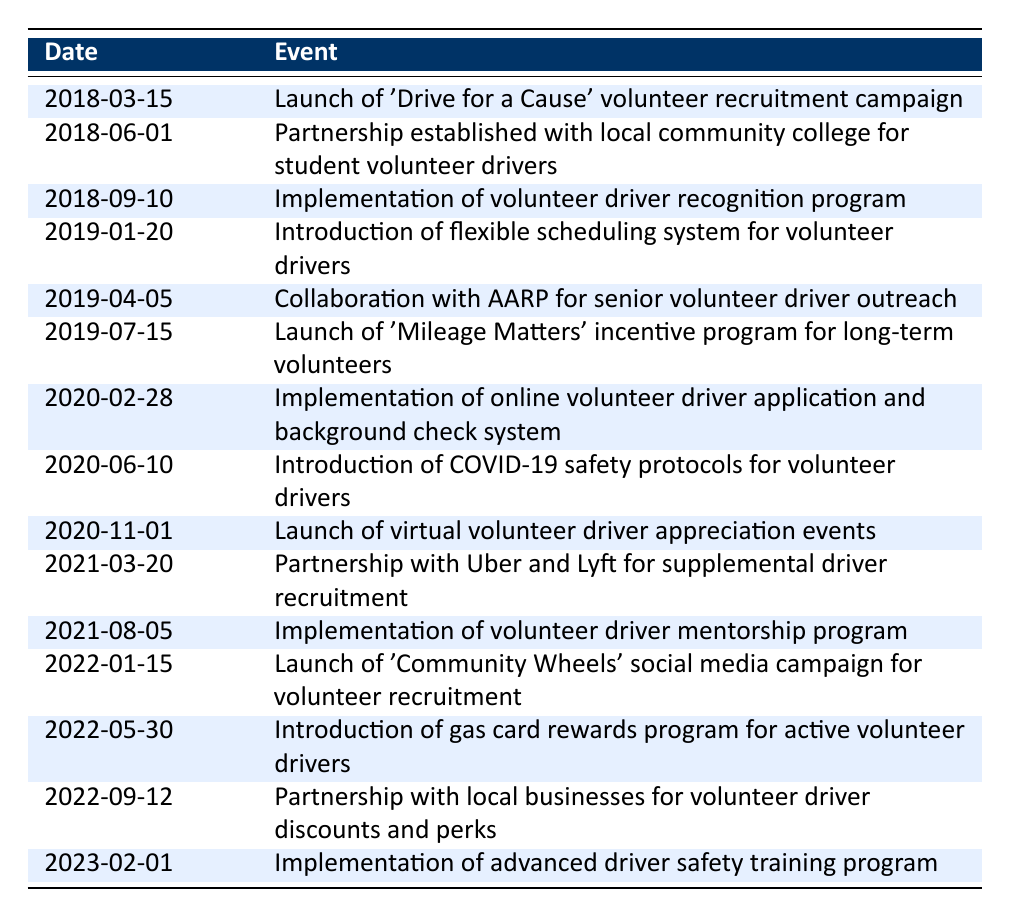What event marked the launch of the volunteer recruitment campaign? The event that marked the launch of the volunteer recruitment campaign is described in the table under the date 2018-03-15, which states "Launch of 'Drive for a Cause' volunteer recruitment campaign."
Answer: Launch of 'Drive for a Cause' volunteer recruitment campaign When did the introduction of the flexible scheduling system occur? Referring to the table, the introduction of the flexible scheduling system occurred on 2019-01-20. This date can be found directly in the date column associated with the relevant event.
Answer: 2019-01-20 How many initiatives were launched to recognize or appreciate volunteer drivers according to the timeline? There are two initiatives related to recognition or appreciation of volunteer drivers mentioned in the table: one on 2018-09-10 for the recognition program and another on 2020-11-01 for virtual appreciation events. Thus, the total is 2.
Answer: 2 Which partnership was established in 2021 to help with driver recruitment? The table indicates that a partnership with Uber and Lyft for supplemental driver recruitment was established on 2021-03-20. This information is directly retrievable from the relevant row.
Answer: Partnership with Uber and Lyft for supplemental driver recruitment Was there any initiative focused on senior volunteer drivers? Yes, according to the table, a collaboration with AARP for senior volunteer driver outreach was established on 2019-04-05, which confirms the initiative's focus on that demographic.
Answer: Yes What was the purpose of the 'Mileage Matters' incentive program that launched in July 2019? The 'Mileage Matters' incentive program launched on 2019-07-15 is explicitly stated in the table as aimed at recognizing long-term volunteers, suggesting its purpose was to incentivize continued involvement.
Answer: To incentivize long-term volunteers List the events that took place in 2020. Reviewing the timeline, three events took place in 2020: the implementation of an online volunteer driver application system on 2020-02-28, the introduction of COVID-19 safety protocols on 2020-06-10, and the launch of virtual appreciation events on 2020-11-01. Therefore, there are three events in total.
Answer: Three events What was the first event related to volunteer driver support in 2022? The first event related to volunteer driver support in 2022, according to the timeline, was the launch of 'Community Wheels' social media campaign for volunteer recruitment, which happened on 2022-01-15. This is confirmed by the order of events in the table.
Answer: Launch of 'Community Wheels' social media campaign for volunteer recruitment How many months apart were the 'Drive for a Cause' campaign and the 'Community Wheels' campaign launches? The 'Drive for a Cause' campaign launched on 2018-03-15, and the 'Community Wheels' campaign launched on 2022-01-15. The difference in months can be calculated by finding the difference in years (2022 - 2018 = 4 years), then converting this to months (4 * 12 = 48 months) and accounting for the specific dates. From March to January of the following year gives 10 months, so in total, it is 46 months apart.
Answer: 46 months apart 